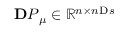Convert formula to latex. <formula><loc_0><loc_0><loc_500><loc_500>{ \mathbf P } _ { \boldsymbol \mu } \in \mathbb { R } ^ { n \times n \mathrm s }</formula> 